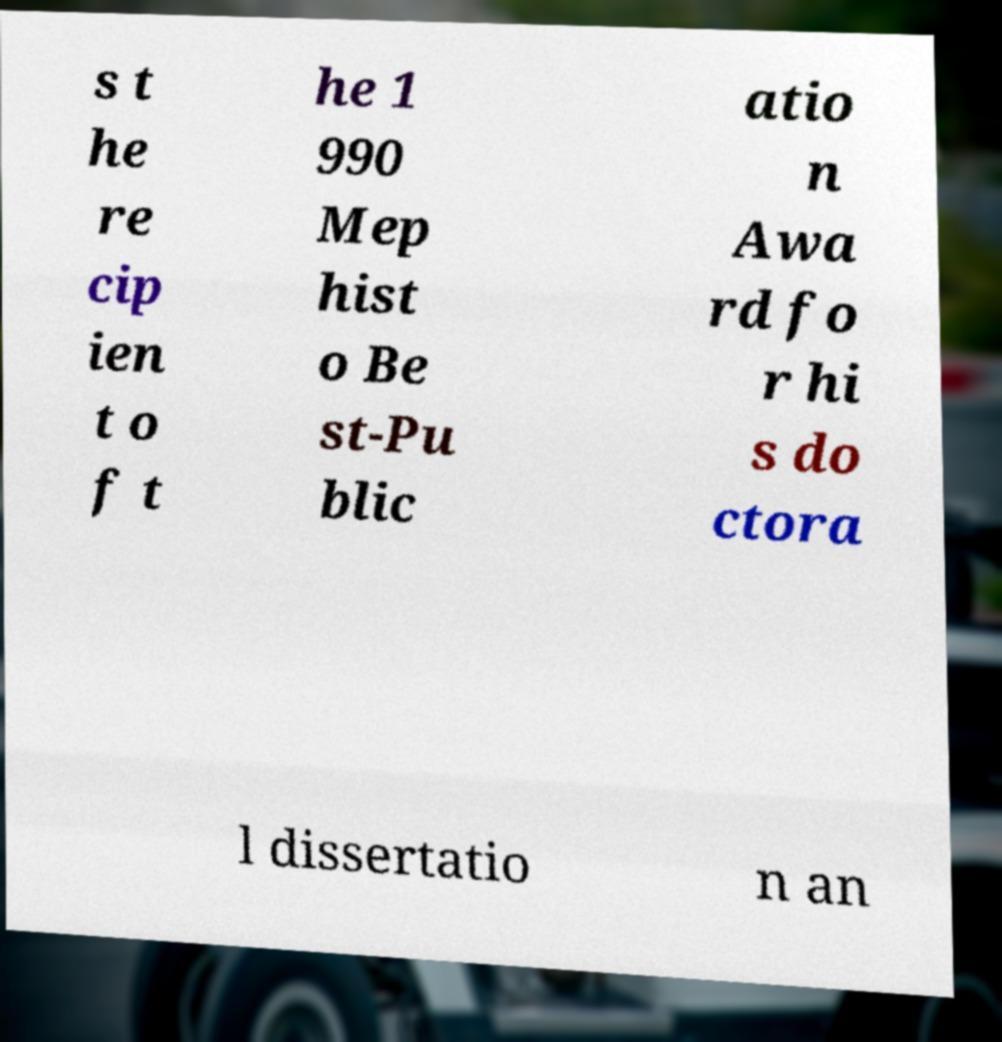Please read and relay the text visible in this image. What does it say? s t he re cip ien t o f t he 1 990 Mep hist o Be st-Pu blic atio n Awa rd fo r hi s do ctora l dissertatio n an 